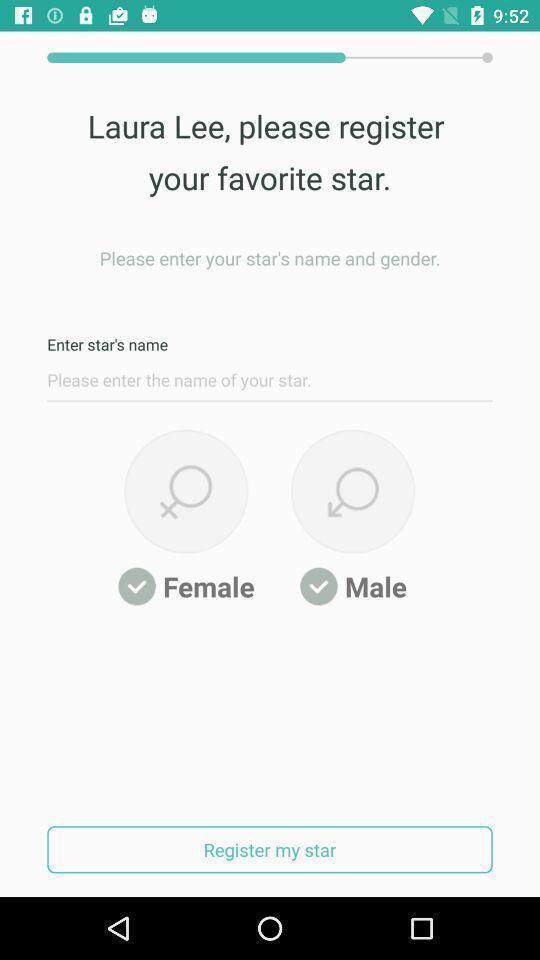Provide a textual representation of this image. Window displaying a app for fans. 